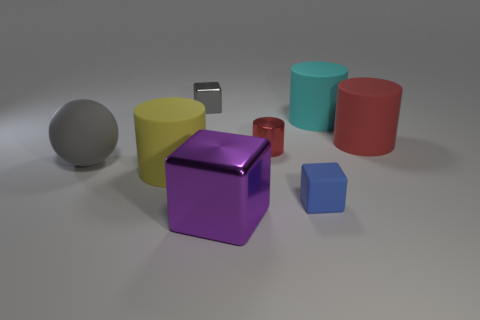The small object to the left of the purple cube has what shape?
Your response must be concise. Cube. There is a red object to the left of the tiny thing in front of the ball; are there any large cylinders left of it?
Offer a terse response. Yes. Are there any other things that have the same shape as the red metal thing?
Your response must be concise. Yes. Are any big blue balls visible?
Make the answer very short. No. Does the tiny thing that is left of the red shiny cylinder have the same material as the large object left of the yellow object?
Make the answer very short. No. There is a metal block behind the red cylinder to the right of the cyan object behind the big yellow matte thing; what is its size?
Provide a short and direct response. Small. How many big yellow objects are made of the same material as the large ball?
Your answer should be compact. 1. Is the number of small red metallic cylinders less than the number of blocks?
Your response must be concise. Yes. What size is the gray object that is the same shape as the small blue rubber thing?
Ensure brevity in your answer.  Small. Is the material of the red object that is in front of the red matte cylinder the same as the small gray cube?
Give a very brief answer. Yes. 